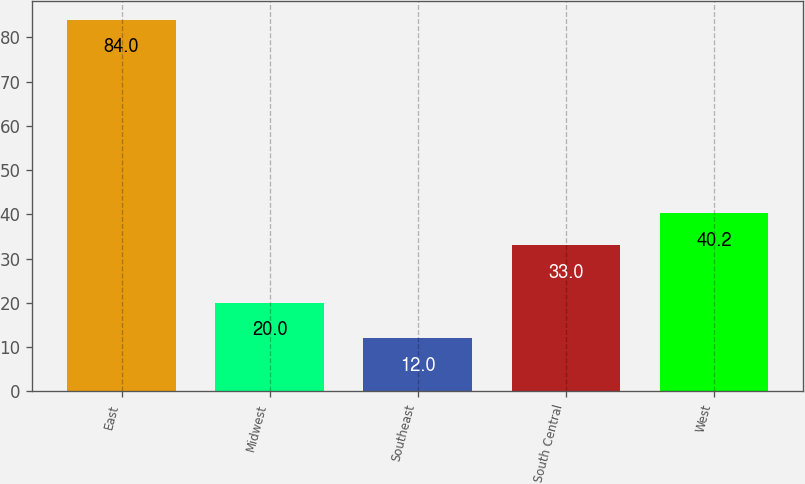<chart> <loc_0><loc_0><loc_500><loc_500><bar_chart><fcel>East<fcel>Midwest<fcel>Southeast<fcel>South Central<fcel>West<nl><fcel>84<fcel>20<fcel>12<fcel>33<fcel>40.2<nl></chart> 